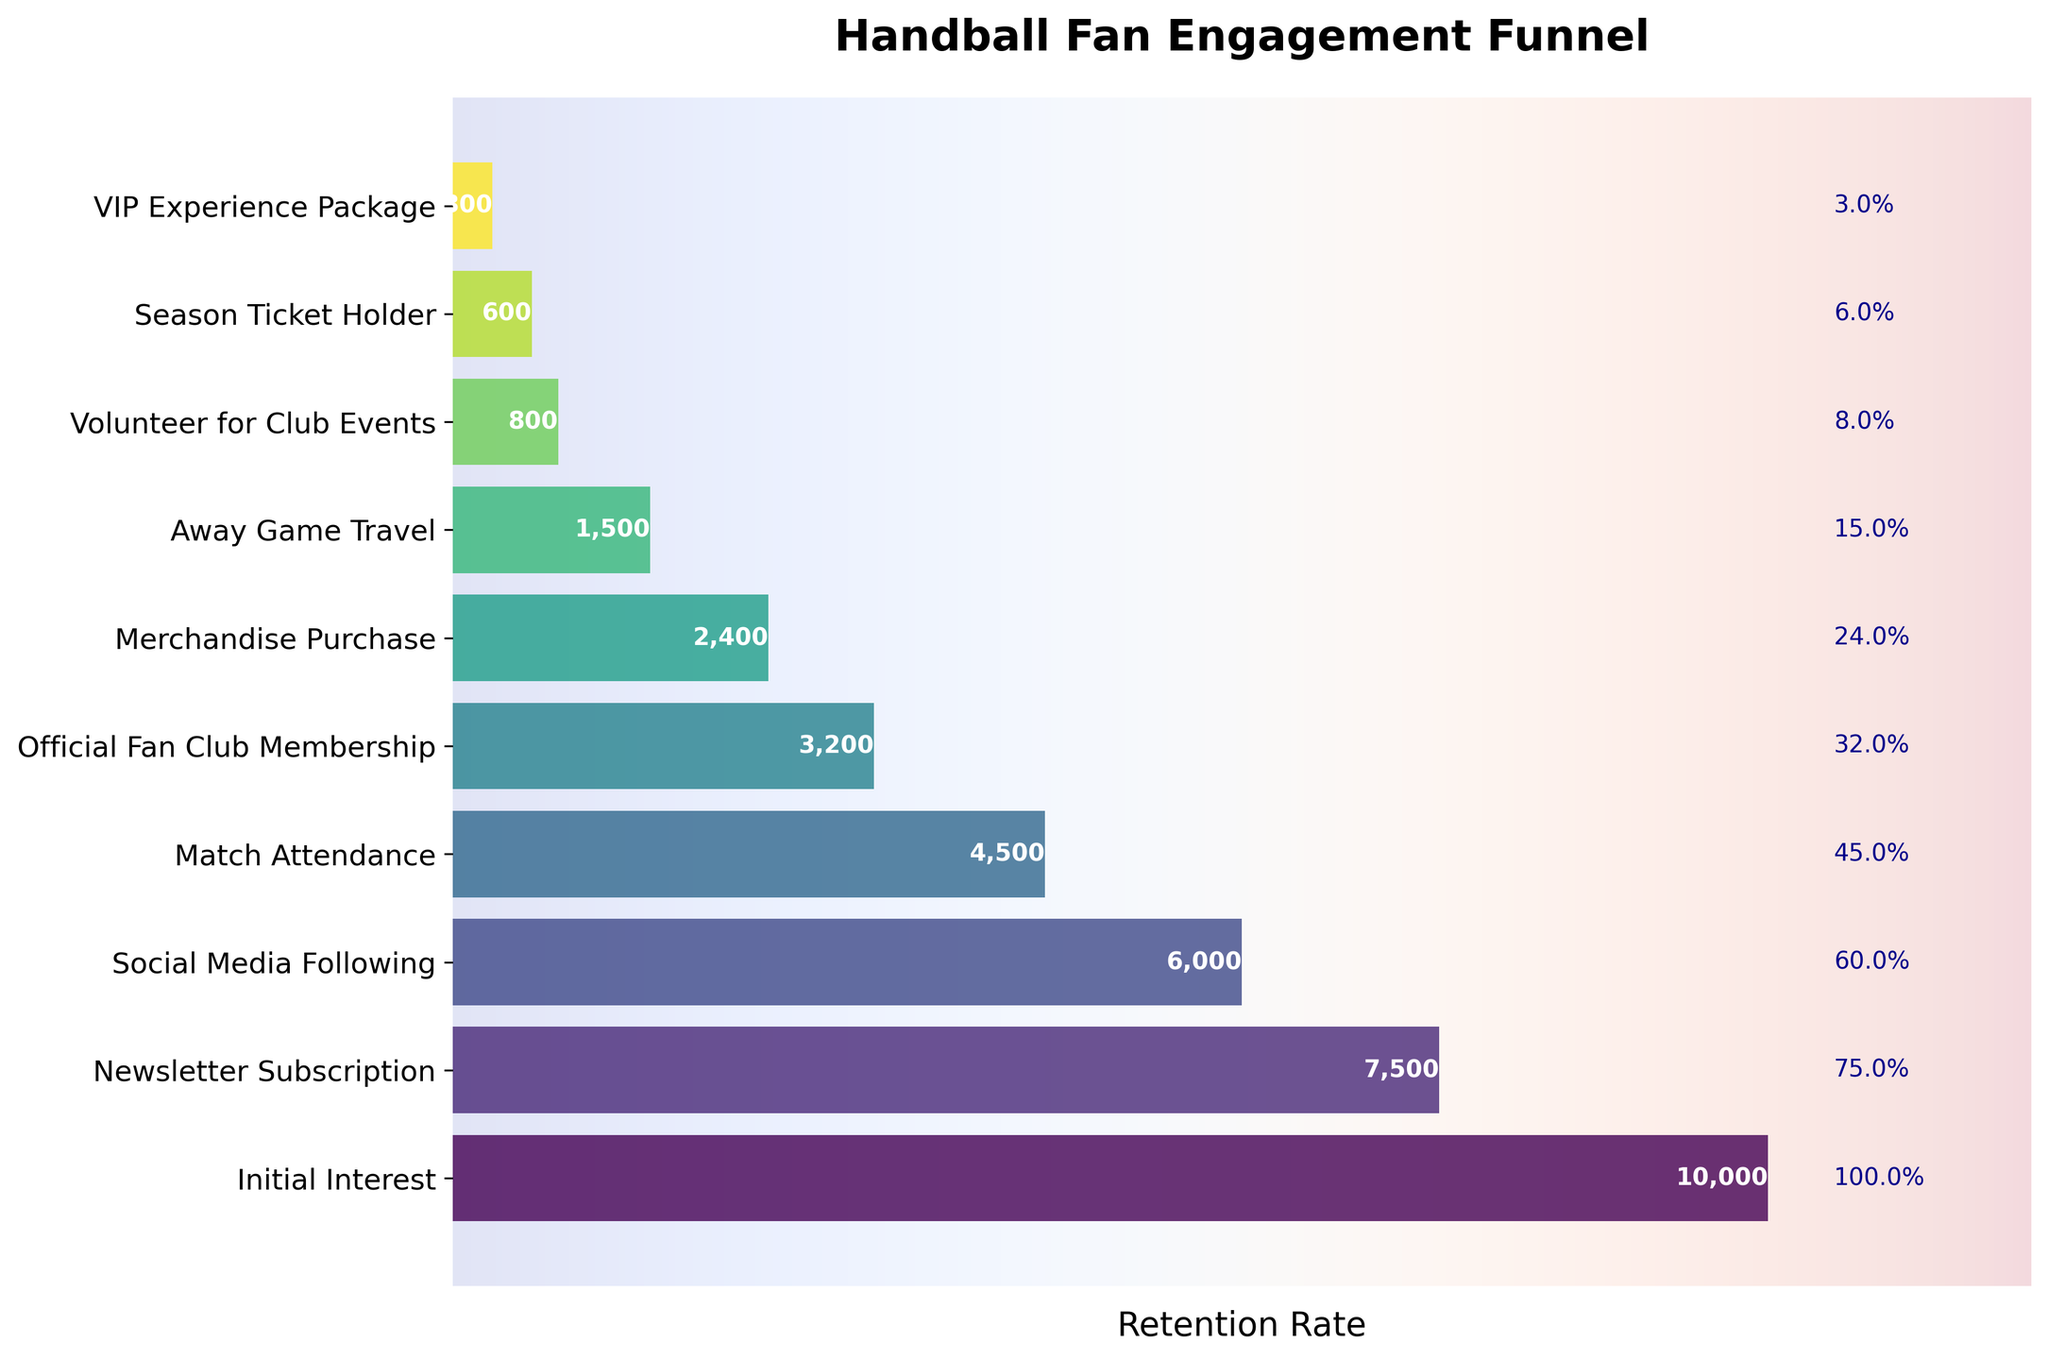What's the title of the figure? The title of the figure is displayed prominently at the top of the chart.
Answer: Handball Fan Engagement Funnel What stage has the highest number of participants? The funnel's widest section from the left indicates the highest number of participants.
Answer: Initial Interest How many participants made it to the Match Attendance stage? The number of participants is directly labeled next to the Match Attendance stage bar.
Answer: 4,500 Which stage has the lowest retention rate? The percentage retention rate is labeled on the right side of each stage bar. The smallest percentage indicates the lowest retention rate.
Answer: VIP Experience Package By how much does the number of participants decline from Newsletter Subscription to Social Media Following? Subtract the number of participants in Social Media Following from the participants in Newsletter Subscription.
Answer: 1,500 What is the retention rate at the Merchandise Purchase stage? The retention rates are labeled to the right of each stage and displayed as a percentage.
Answer: 24.0% Which stage shows the largest drop in the number of participants compared to its previous stage? Locate the largest difference in the length of the horizontal bars between successive stages. The drop between Match Attendance (4,500 participants) and Official Fan Club Membership (3,200 participants) is the highest.
Answer: Match Attendance to Official Fan Club Membership How many stages have a retention rate of 10% or lower? Count the number of stages where the percentage display is 10% or less. These stages are: Volunteer for Club Events (8%) and VIP Experience Package (3%).
Answer: 2 What percentage of the Initial Interest group becomes Season Ticket Holders? Divide the number of Season Ticket Holders by the number of Initial Interest participants and multiply by 100.
Answer: 6.0% Compare the number of participants in the Social Media Following stage and the Official Fan Club Membership stage. Look at the number of participants labeled next to each stage to compare the values. Social Media Following has 6,000 participants, and Official Fan Club Membership has 3,200 participants.
Answer: Social Media Following has more participants than Official Fan Club Membership 